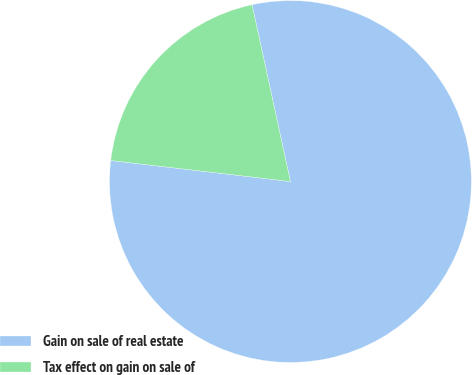<chart> <loc_0><loc_0><loc_500><loc_500><pie_chart><fcel>Gain on sale of real estate<fcel>Tax effect on gain on sale of<nl><fcel>80.26%<fcel>19.74%<nl></chart> 